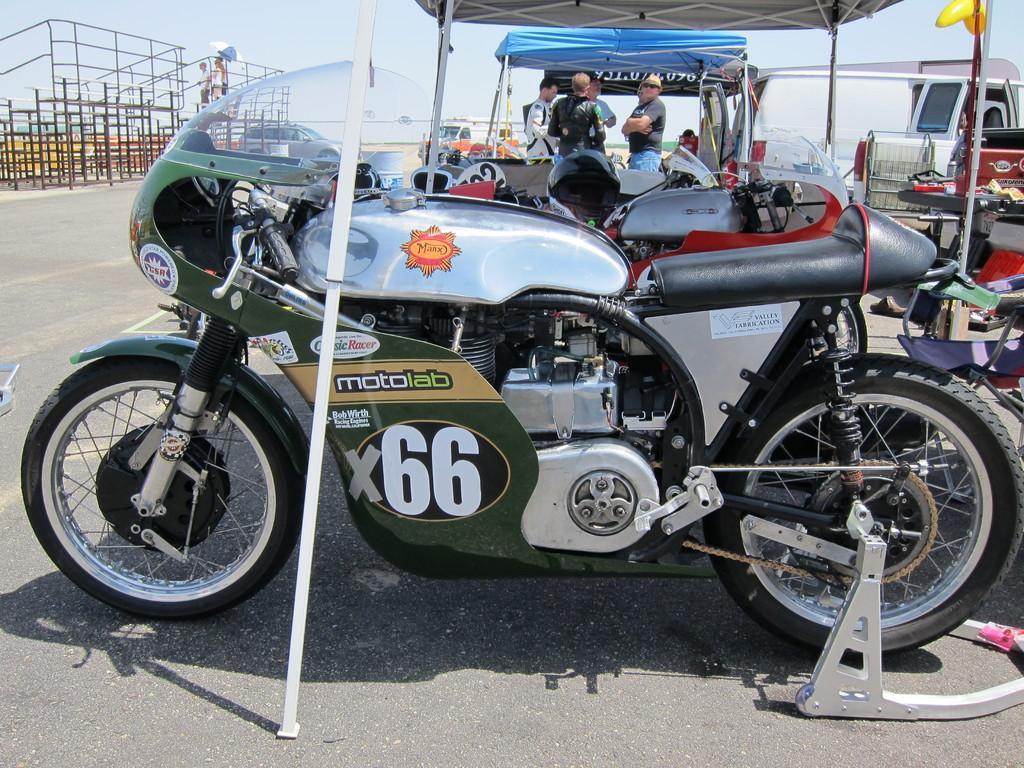Could you give a brief overview of what you see in this image? In the background we can see the sky. In this picture we can see the parking area under the tents. We can see the people and vehicles. On the left side of the picture we can see the railings and people. We can see an umbrella. At the bottom portion of the picture we can see the road. 